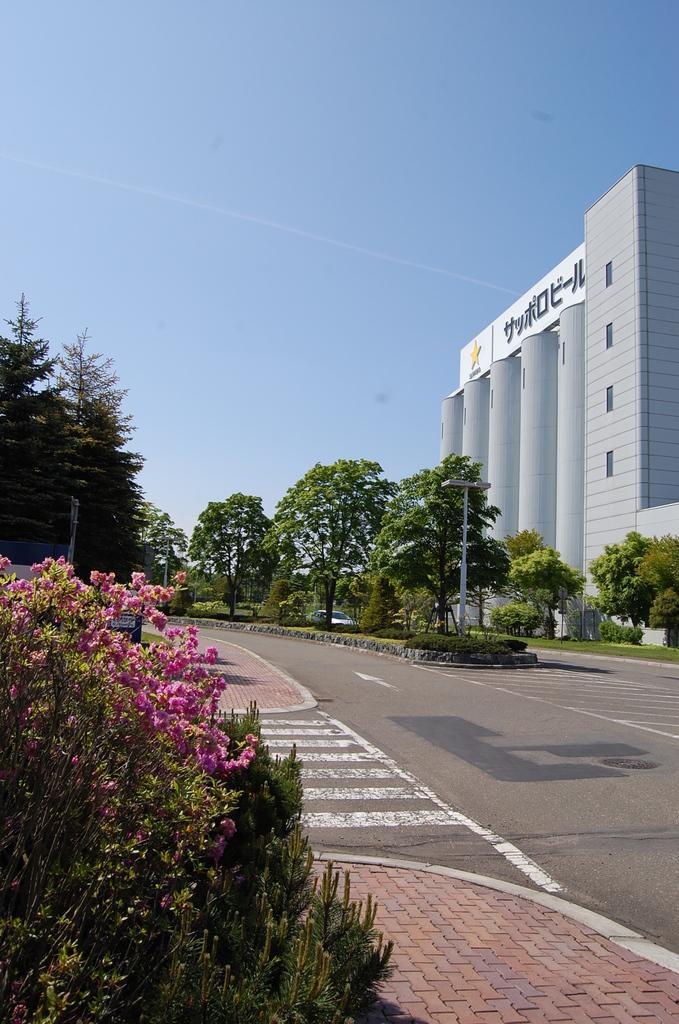Could you give a brief overview of what you see in this image? In this picture we can see plants, flowers, car on the road, poles, trees and building. In the background of the image we can see the sky. 